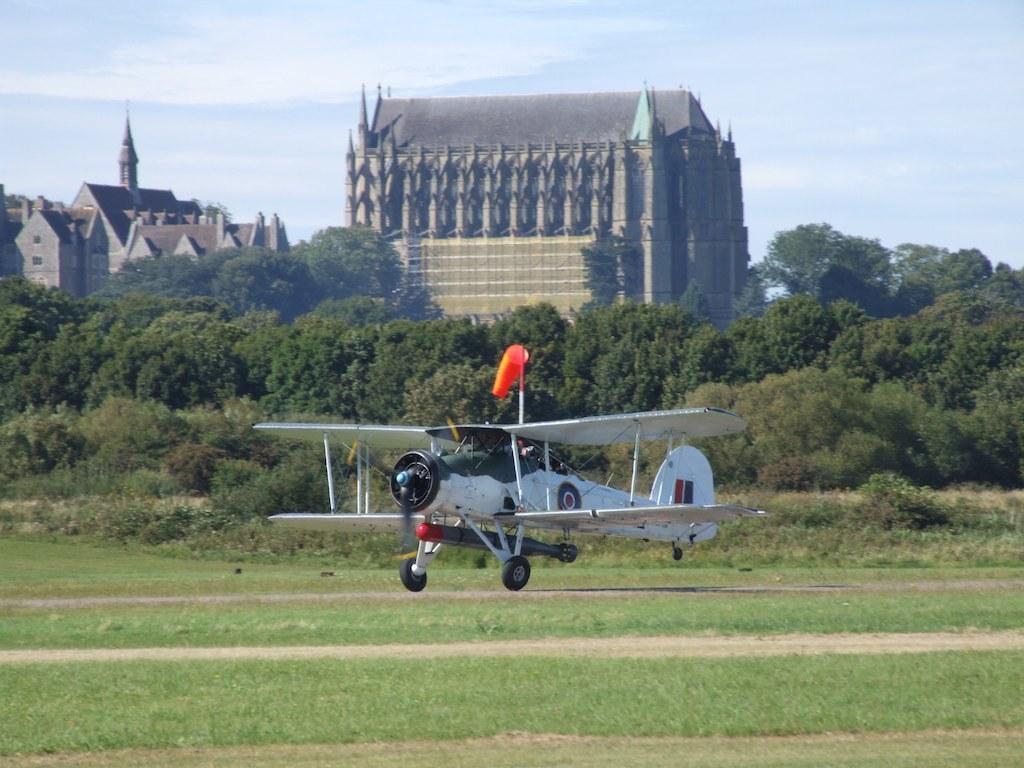Can you describe this image briefly? In this image we can see a plane on a pathway. We can also see some grass and the trees. On the backside we can see some houses with roof and the sky which looks cloudy. 